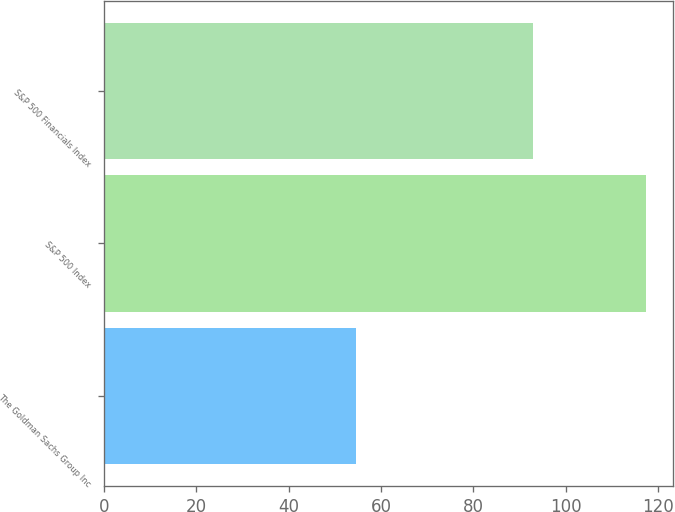<chart> <loc_0><loc_0><loc_500><loc_500><bar_chart><fcel>The Goldman Sachs Group Inc<fcel>S&P 500 Index<fcel>S&P 500 Financials Index<nl><fcel>54.69<fcel>117.49<fcel>93<nl></chart> 